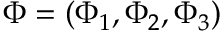<formula> <loc_0><loc_0><loc_500><loc_500>\Phi = ( \Phi _ { 1 } , \Phi _ { 2 } , \Phi _ { 3 } )</formula> 